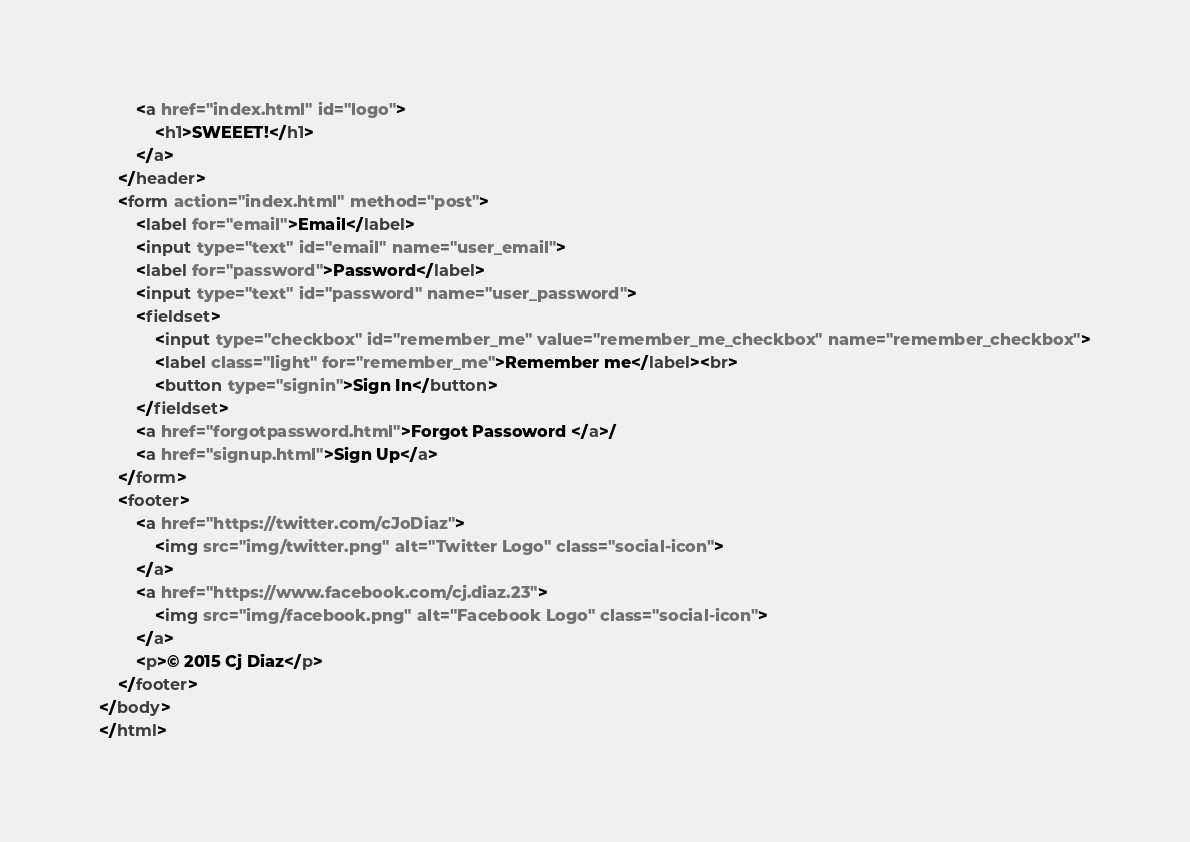<code> <loc_0><loc_0><loc_500><loc_500><_HTML_>		<a href="index.html" id="logo">
			<h1>SWEEET!</h1>
		</a>
	</header>
	<form action="index.html" method="post">
		<label for="email">Email</label>
		<input type="text" id="email" name="user_email">
		<label for="password">Password</label>
		<input type="text" id="password" name="user_password">
		<fieldset>
			<input type="checkbox" id="remember_me" value="remember_me_checkbox" name="remember_checkbox">
			<label class="light" for="remember_me">Remember me</label><br>
			<button type="signin">Sign In</button>
		</fieldset>
		<a href="forgotpassword.html">Forgot Passoword </a>/
		<a href="signup.html">Sign Up</a>
	</form>
	<footer>
		<a href="https://twitter.com/cJoDiaz">
			<img src="img/twitter.png" alt="Twitter Logo" class="social-icon">
		</a>
		<a href="https://www.facebook.com/cj.diaz.23">
			<img src="img/facebook.png" alt="Facebook Logo" class="social-icon">
		</a>
		<p>© 2015 Cj Diaz</p>
	</footer>
</body>
</html></code> 